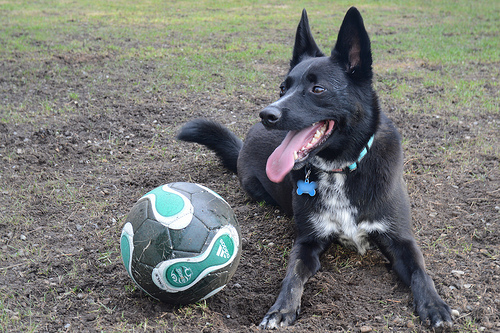<image>
Is there a ball on the dog? No. The ball is not positioned on the dog. They may be near each other, but the ball is not supported by or resting on top of the dog. 